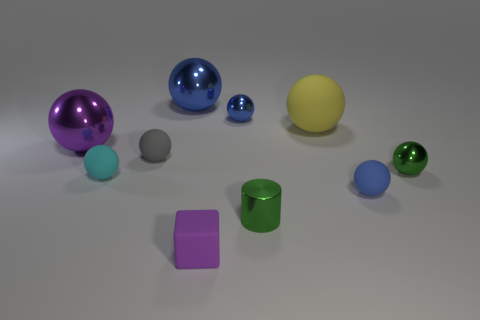There is a tiny gray object that is in front of the big rubber object; is its shape the same as the small blue metallic thing?
Provide a short and direct response. Yes. Do the big purple metal object and the large metallic thing that is behind the tiny blue metal sphere have the same shape?
Offer a terse response. Yes. What number of balls are red matte things or yellow rubber things?
Your answer should be very brief. 1. Is the shape of the tiny cyan rubber thing the same as the small purple object?
Your answer should be compact. No. What is the size of the blue metal sphere in front of the big blue metallic ball?
Ensure brevity in your answer.  Small. Are there any big spheres that have the same color as the rubber block?
Give a very brief answer. Yes. There is a green object in front of the cyan matte sphere; does it have the same size as the small gray object?
Your response must be concise. Yes. The large matte thing has what color?
Your answer should be very brief. Yellow. What is the color of the metal sphere that is to the right of the matte ball that is right of the large yellow rubber thing?
Your answer should be very brief. Green. Are there any tiny blue things made of the same material as the tiny cyan thing?
Ensure brevity in your answer.  Yes. 